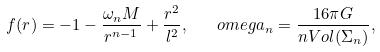<formula> <loc_0><loc_0><loc_500><loc_500>f ( r ) = - 1 - \frac { \omega _ { n } M } { r ^ { n - 1 } } + \frac { r ^ { 2 } } { l ^ { 2 } } , \ \ \ o m e g a _ { n } = \frac { 1 6 \pi G } { n V o l ( \Sigma _ { n } ) } ,</formula> 